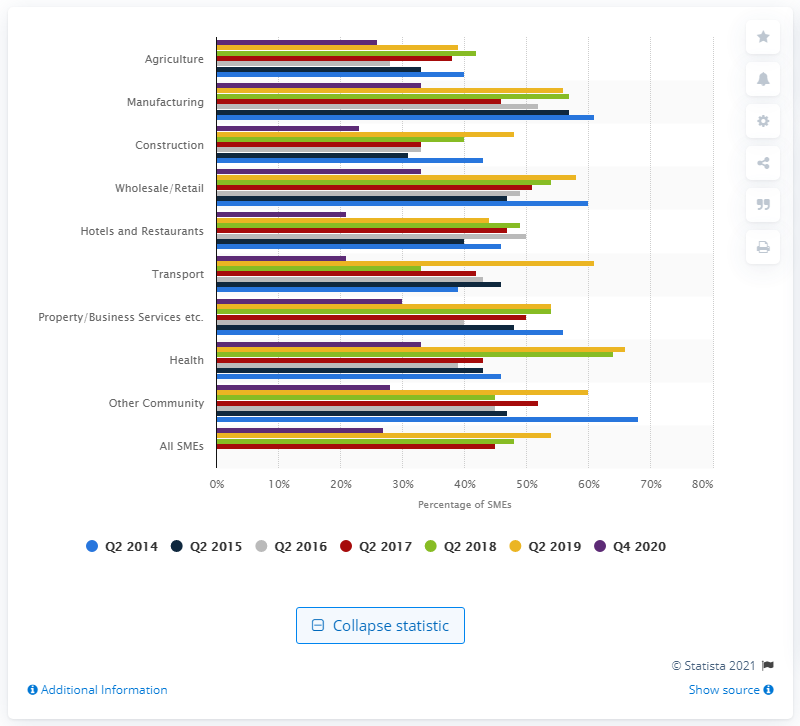Give some essential details in this illustration. According to a recent survey of small and medium-sized enterprises (SMEs) in the health sector, 33% of respondents reported that they expected to experience substantial or moderate growth in the next 12 months. 